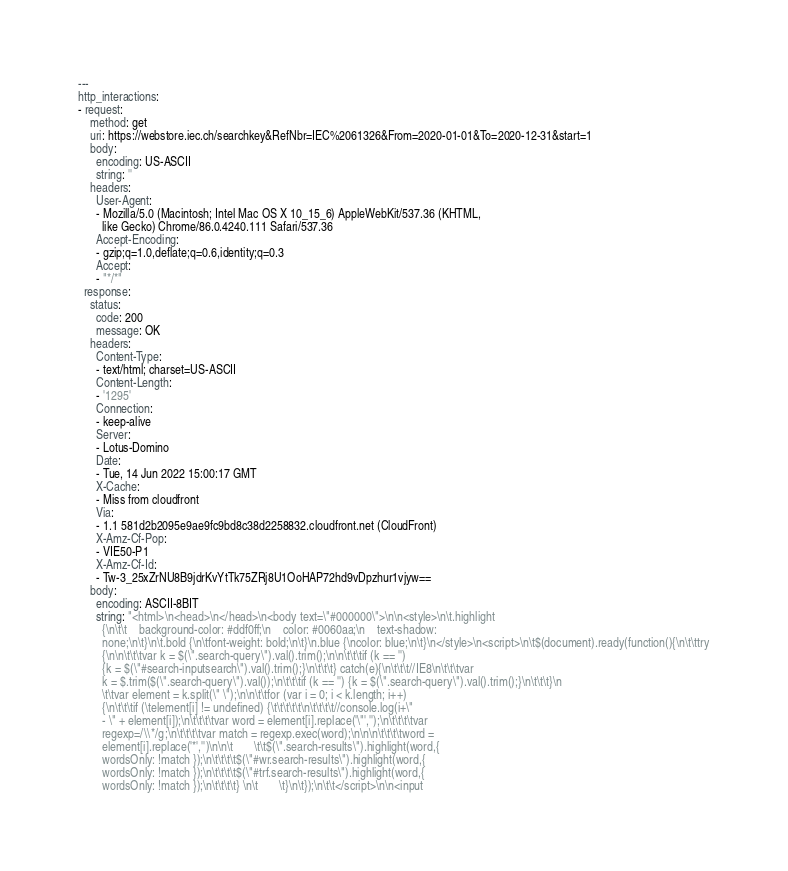Convert code to text. <code><loc_0><loc_0><loc_500><loc_500><_YAML_>---
http_interactions:
- request:
    method: get
    uri: https://webstore.iec.ch/searchkey&RefNbr=IEC%2061326&From=2020-01-01&To=2020-12-31&start=1
    body:
      encoding: US-ASCII
      string: ''
    headers:
      User-Agent:
      - Mozilla/5.0 (Macintosh; Intel Mac OS X 10_15_6) AppleWebKit/537.36 (KHTML,
        like Gecko) Chrome/86.0.4240.111 Safari/537.36
      Accept-Encoding:
      - gzip;q=1.0,deflate;q=0.6,identity;q=0.3
      Accept:
      - "*/*"
  response:
    status:
      code: 200
      message: OK
    headers:
      Content-Type:
      - text/html; charset=US-ASCII
      Content-Length:
      - '1295'
      Connection:
      - keep-alive
      Server:
      - Lotus-Domino
      Date:
      - Tue, 14 Jun 2022 15:00:17 GMT
      X-Cache:
      - Miss from cloudfront
      Via:
      - 1.1 581d2b2095e9ae9fc9bd8c38d2258832.cloudfront.net (CloudFront)
      X-Amz-Cf-Pop:
      - VIE50-P1
      X-Amz-Cf-Id:
      - Tw-3_25xZrNU8B9jdrKvYtTk75ZRj8U1OoHAP72hd9vDpzhur1vjyw==
    body:
      encoding: ASCII-8BIT
      string: "<html>\n<head>\n</head>\n<body text=\"#000000\">\n\n<style>\n\t.highlight
        {\n\t\t    background-color: #ddf0ff;\n    color: #0060aa;\n    text-shadow:
        none;\n\t}\n\t.bold {\n\tfont-weight: bold;\n\t}\n.blue {\ncolor: blue;\n\t}\n</style>\n<script>\n\t$(document).ready(function(){\n\t\ttry
        {\n\n\t\t\tvar k = $(\".search-query\").val().trim();\n\n\t\t\tif (k == '')
        {k = $(\"#search-inputsearch\").val().trim();}\n\t\t\t} catch(e){\n\t\t\t//IE8\n\t\t\tvar
        k = $.trim($(\".search-query\").val());\n\t\t\tif (k == '') {k = $(\".search-query\").val().trim();}\n\t\t\t}\n
        \t\tvar element = k.split(\" \");\n\n\t\tfor (var i = 0; i < k.length; i++)
        {\n\t\t\tif (\telement[i] != undefined) {\t\t\t\t\t\n\t\t\t\t//console.log(i+\"
        - \" + element[i]);\n\t\t\t\tvar word = element[i].replace('\"','');\n\t\t\t\tvar
        regexp=/\\*/g;\n\t\t\t\tvar match = regexp.exec(word);\n\n\n\t\t\t\tword =
        element[i].replace('*','')\n\n\t       \t\t$(\".search-results\").highlight(word,{
        wordsOnly: !match });\n\t\t\t\t$(\"#wr.search-results\").highlight(word,{
        wordsOnly: !match });\n\t\t\t\t$(\"#trf.search-results\").highlight(word,{
        wordsOnly: !match });\n\t\t\t\t} \n\t       \t}\n\t});\n\t\t</script>\n\n<input</code> 